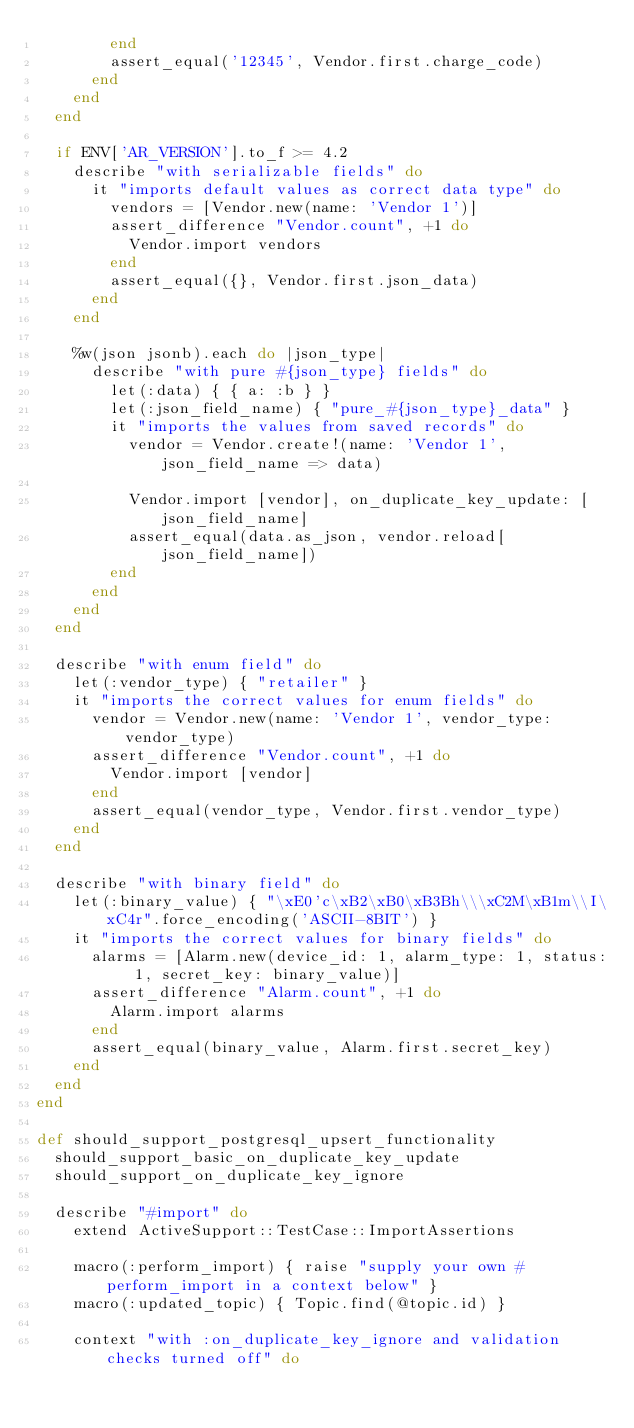Convert code to text. <code><loc_0><loc_0><loc_500><loc_500><_Ruby_>        end
        assert_equal('12345', Vendor.first.charge_code)
      end
    end
  end

  if ENV['AR_VERSION'].to_f >= 4.2
    describe "with serializable fields" do
      it "imports default values as correct data type" do
        vendors = [Vendor.new(name: 'Vendor 1')]
        assert_difference "Vendor.count", +1 do
          Vendor.import vendors
        end
        assert_equal({}, Vendor.first.json_data)
      end
    end

    %w(json jsonb).each do |json_type|
      describe "with pure #{json_type} fields" do
        let(:data) { { a: :b } }
        let(:json_field_name) { "pure_#{json_type}_data" }
        it "imports the values from saved records" do
          vendor = Vendor.create!(name: 'Vendor 1', json_field_name => data)

          Vendor.import [vendor], on_duplicate_key_update: [json_field_name]
          assert_equal(data.as_json, vendor.reload[json_field_name])
        end
      end
    end
  end

  describe "with enum field" do
    let(:vendor_type) { "retailer" }
    it "imports the correct values for enum fields" do
      vendor = Vendor.new(name: 'Vendor 1', vendor_type: vendor_type)
      assert_difference "Vendor.count", +1 do
        Vendor.import [vendor]
      end
      assert_equal(vendor_type, Vendor.first.vendor_type)
    end
  end

  describe "with binary field" do
    let(:binary_value) { "\xE0'c\xB2\xB0\xB3Bh\\\xC2M\xB1m\\I\xC4r".force_encoding('ASCII-8BIT') }
    it "imports the correct values for binary fields" do
      alarms = [Alarm.new(device_id: 1, alarm_type: 1, status: 1, secret_key: binary_value)]
      assert_difference "Alarm.count", +1 do
        Alarm.import alarms
      end
      assert_equal(binary_value, Alarm.first.secret_key)
    end
  end
end

def should_support_postgresql_upsert_functionality
  should_support_basic_on_duplicate_key_update
  should_support_on_duplicate_key_ignore

  describe "#import" do
    extend ActiveSupport::TestCase::ImportAssertions

    macro(:perform_import) { raise "supply your own #perform_import in a context below" }
    macro(:updated_topic) { Topic.find(@topic.id) }

    context "with :on_duplicate_key_ignore and validation checks turned off" do</code> 